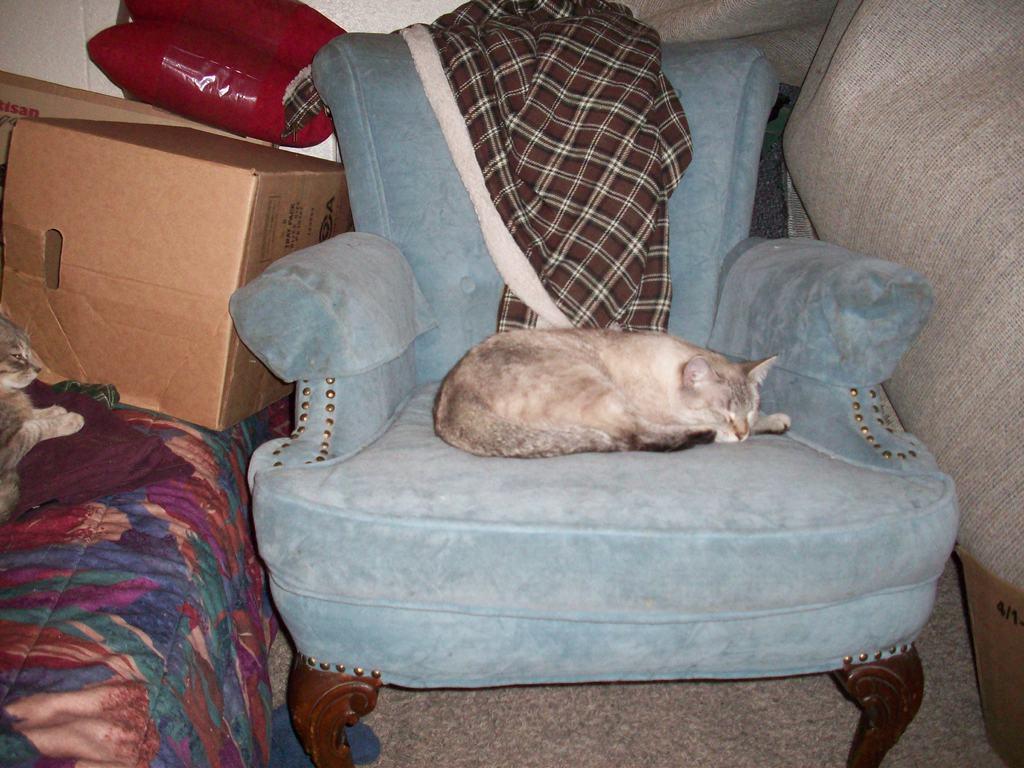Can you describe this image briefly? As we can see in the image, there is a box, bed and cat on sofa. 